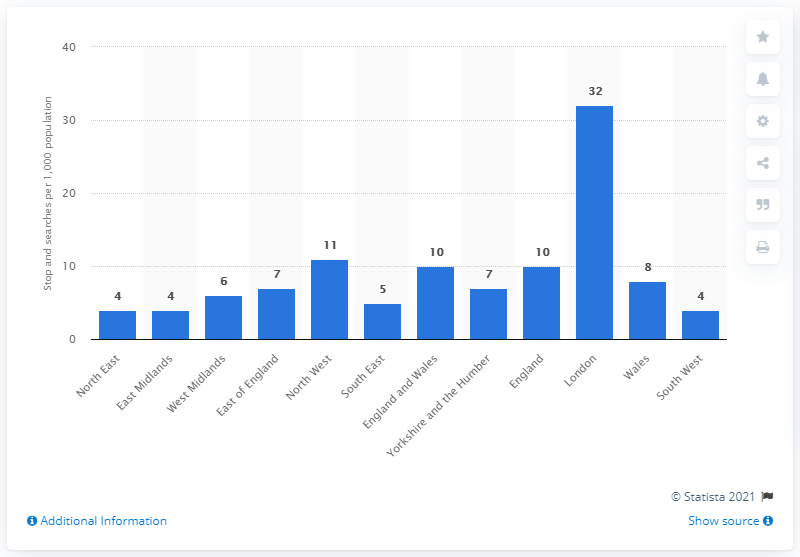Mention a couple of crucial points in this snapshot. The most widespread practice of stop and search in England and Wales is in London. 